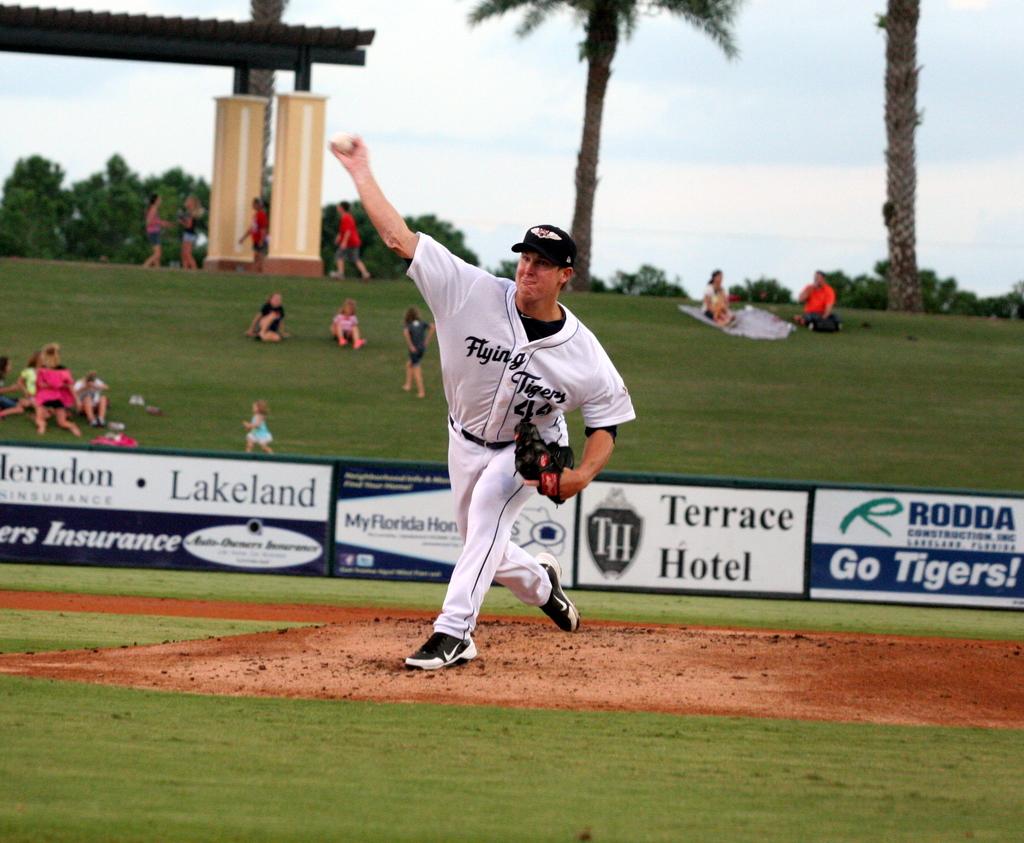What is the name of the hotel?
Make the answer very short. Terrace. What is the name of the team?
Your answer should be very brief. Flying tigers. 